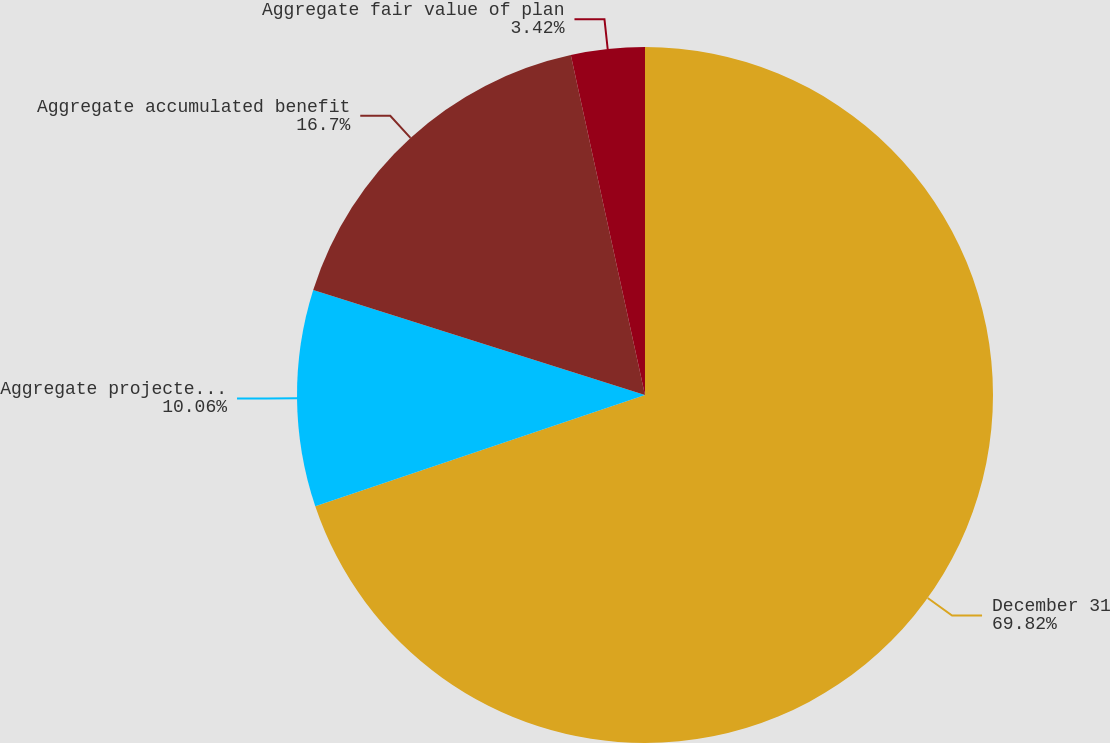Convert chart to OTSL. <chart><loc_0><loc_0><loc_500><loc_500><pie_chart><fcel>December 31<fcel>Aggregate projected benefit<fcel>Aggregate accumulated benefit<fcel>Aggregate fair value of plan<nl><fcel>69.82%<fcel>10.06%<fcel>16.7%<fcel>3.42%<nl></chart> 